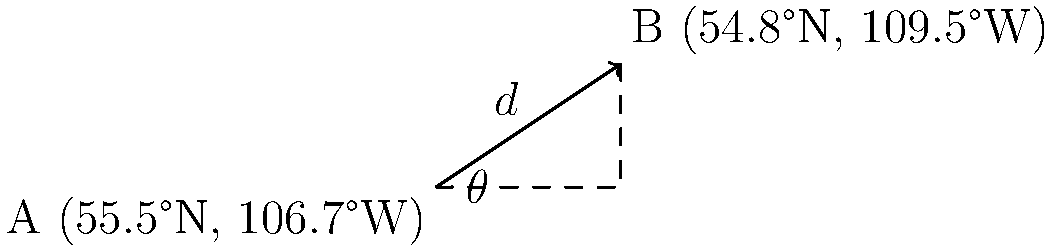Two Indigenous cultural sites, A and B, are located at coordinates (55.5°N, 106.7°W) and (54.8°N, 109.5°W) respectively. Using the given information and the spherical law of cosines, calculate the approximate distance $d$ between these two sites in kilometers. Assume the Earth's radius is 6371 km and round your answer to the nearest kilometer. To solve this problem, we'll use the spherical law of cosines:

$$d = R \cdot \arccos(\sin(\phi_1)\sin(\phi_2) + \cos(\phi_1)\cos(\phi_2)\cos(\Delta \lambda))$$

Where:
$R$ = Earth's radius (6371 km)
$\phi_1, \phi_2$ = latitudes of points A and B in radians
$\Delta \lambda$ = difference in longitudes in radians

Step 1: Convert latitudes and longitudes to radians
$\phi_1 = 55.5° \cdot \frac{\pi}{180} = 0.9686$ radians
$\phi_2 = 54.8° \cdot \frac{\pi}{180} = 0.9565$ radians
$\lambda_1 = -106.7° \cdot \frac{\pi}{180} = -1.8621$ radians
$\lambda_2 = -109.5° \cdot \frac{\pi}{180} = -1.9111$ radians

Step 2: Calculate $\Delta \lambda$
$\Delta \lambda = \lambda_2 - \lambda_1 = -1.9111 - (-1.8621) = -0.0490$ radians

Step 3: Apply the spherical law of cosines
$d = 6371 \cdot \arccos(\sin(0.9686)\sin(0.9565) + \cos(0.9686)\cos(0.9565)\cos(-0.0490))$

Step 4: Calculate the result
$d = 6371 \cdot \arccos(0.9986) = 6371 \cdot 0.0529 = 337.2$ km

Step 5: Round to the nearest kilometer
$d \approx 337$ km
Answer: 337 km 